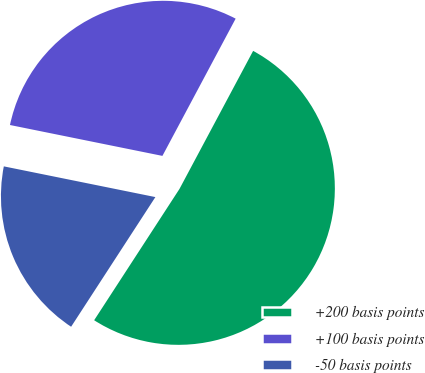<chart> <loc_0><loc_0><loc_500><loc_500><pie_chart><fcel>+200 basis points<fcel>+100 basis points<fcel>-50 basis points<nl><fcel>51.37%<fcel>29.62%<fcel>19.01%<nl></chart> 